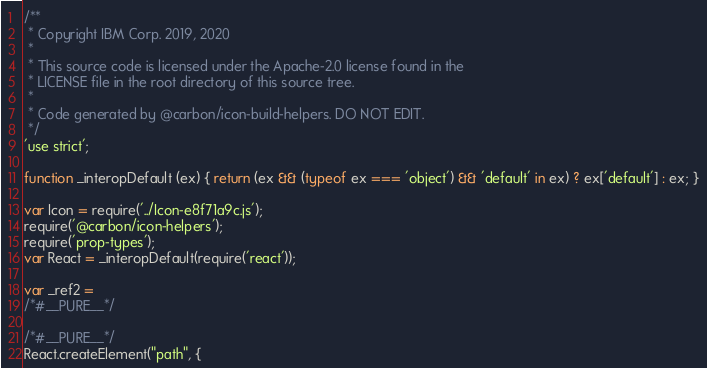Convert code to text. <code><loc_0><loc_0><loc_500><loc_500><_JavaScript_>/**
 * Copyright IBM Corp. 2019, 2020
 *
 * This source code is licensed under the Apache-2.0 license found in the
 * LICENSE file in the root directory of this source tree.
 *
 * Code generated by @carbon/icon-build-helpers. DO NOT EDIT.
 */
'use strict';

function _interopDefault (ex) { return (ex && (typeof ex === 'object') && 'default' in ex) ? ex['default'] : ex; }

var Icon = require('../Icon-e8f71a9c.js');
require('@carbon/icon-helpers');
require('prop-types');
var React = _interopDefault(require('react'));

var _ref2 =
/*#__PURE__*/

/*#__PURE__*/
React.createElement("path", {</code> 